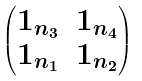Convert formula to latex. <formula><loc_0><loc_0><loc_500><loc_500>\begin{pmatrix} 1 _ { n _ { 3 } } & 1 _ { n _ { 4 } } \\ 1 _ { n _ { 1 } } & 1 _ { n _ { 2 } } \end{pmatrix}</formula> 